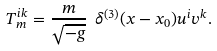<formula> <loc_0><loc_0><loc_500><loc_500>T ^ { i k } _ { m } = \frac { m } { \sqrt { - g } } \ \delta ^ { ( 3 ) } ( x - x _ { 0 } ) u ^ { i } v ^ { k } .</formula> 